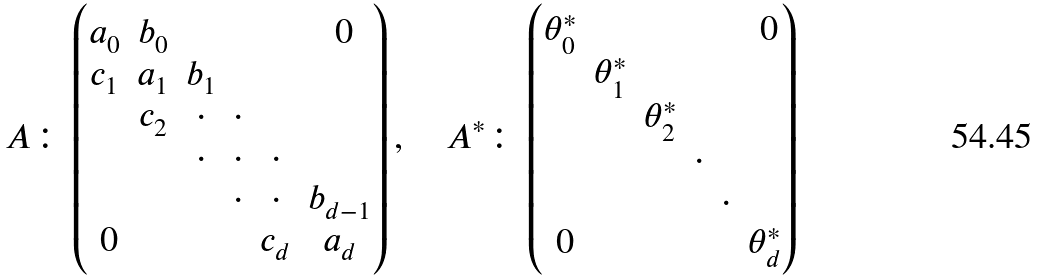<formula> <loc_0><loc_0><loc_500><loc_500>A \colon \begin{pmatrix} a _ { 0 } & b _ { 0 } & & & & \text { 0} \\ c _ { 1 } & a _ { 1 } & b _ { 1 } \\ & c _ { 2 } & \cdot & \cdot \\ & & \cdot & \cdot & \cdot \\ & & & \cdot & \cdot & b _ { d - 1 } \\ \text { 0} & & & & c _ { d } & a _ { d } \end{pmatrix} , \quad A ^ { * } \colon \begin{pmatrix} \theta ^ { * } _ { 0 } & & & & & \text { 0} \\ & \theta ^ { * } _ { 1 } \\ & & \theta ^ { * } _ { 2 } \\ & & & \cdot \\ & & & & \cdot \\ \text { 0} & & & & & \theta ^ { * } _ { d } \end{pmatrix}</formula> 